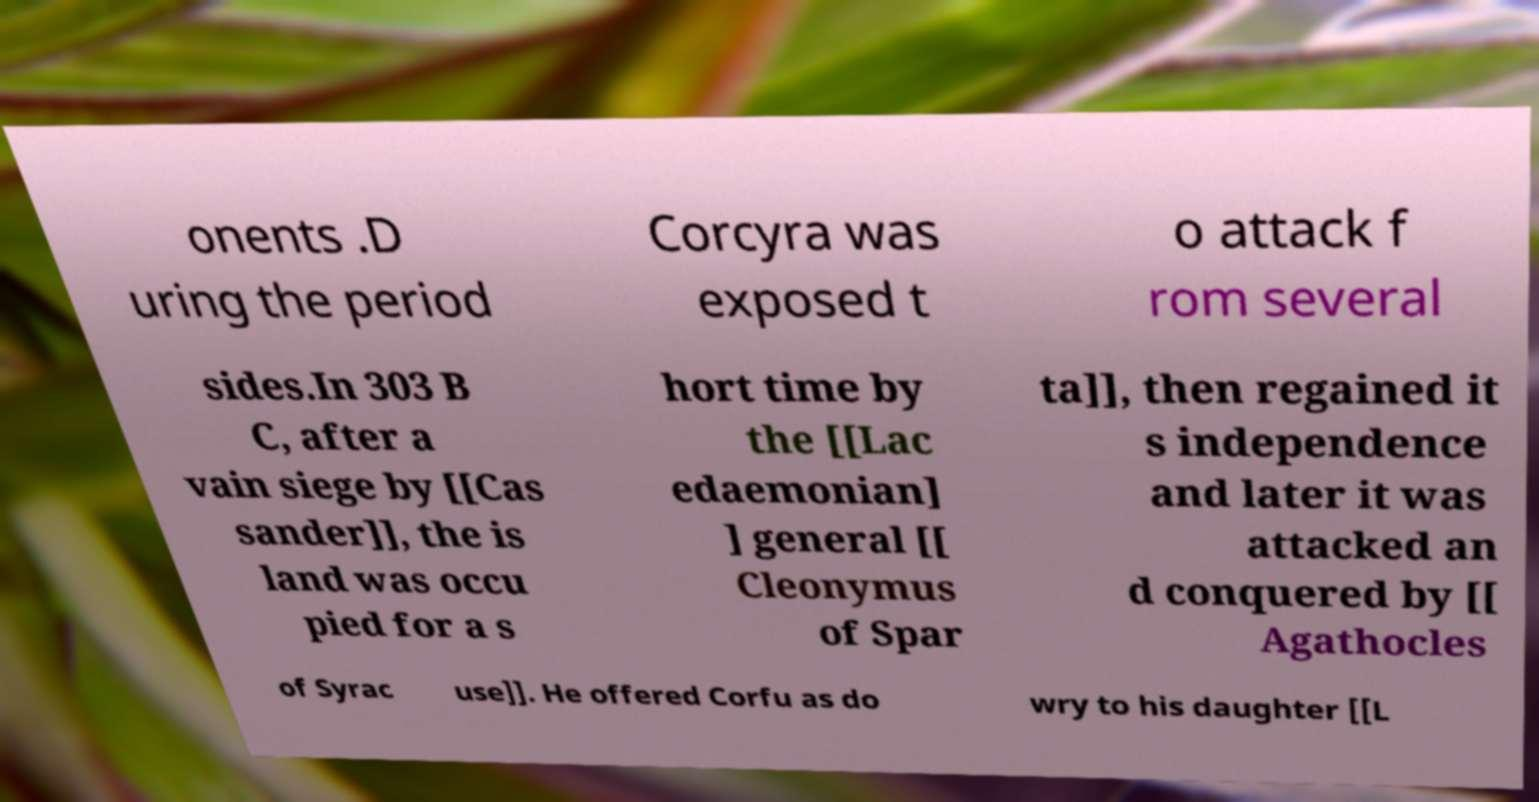Please read and relay the text visible in this image. What does it say? onents .D uring the period Corcyra was exposed t o attack f rom several sides.In 303 B C, after a vain siege by [[Cas sander]], the is land was occu pied for a s hort time by the [[Lac edaemonian] ] general [[ Cleonymus of Spar ta]], then regained it s independence and later it was attacked an d conquered by [[ Agathocles of Syrac use]]. He offered Corfu as do wry to his daughter [[L 